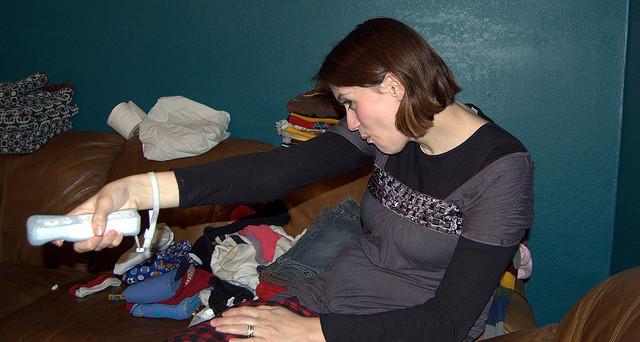What is the white cord attached to?
Quick response, please. Wrist. Is the woman having fun?
Answer briefly. Yes. Is this woman smoking?
Quick response, please. No. How many hands is she using to hold controllers?
Write a very short answer. 1. What game system are they using?
Give a very brief answer. Wii. Is the woman playing alone?
Keep it brief. Yes. Is this women drunk?
Write a very short answer. No. What is the woman in the blue dress holding?
Answer briefly. Wiimote. 